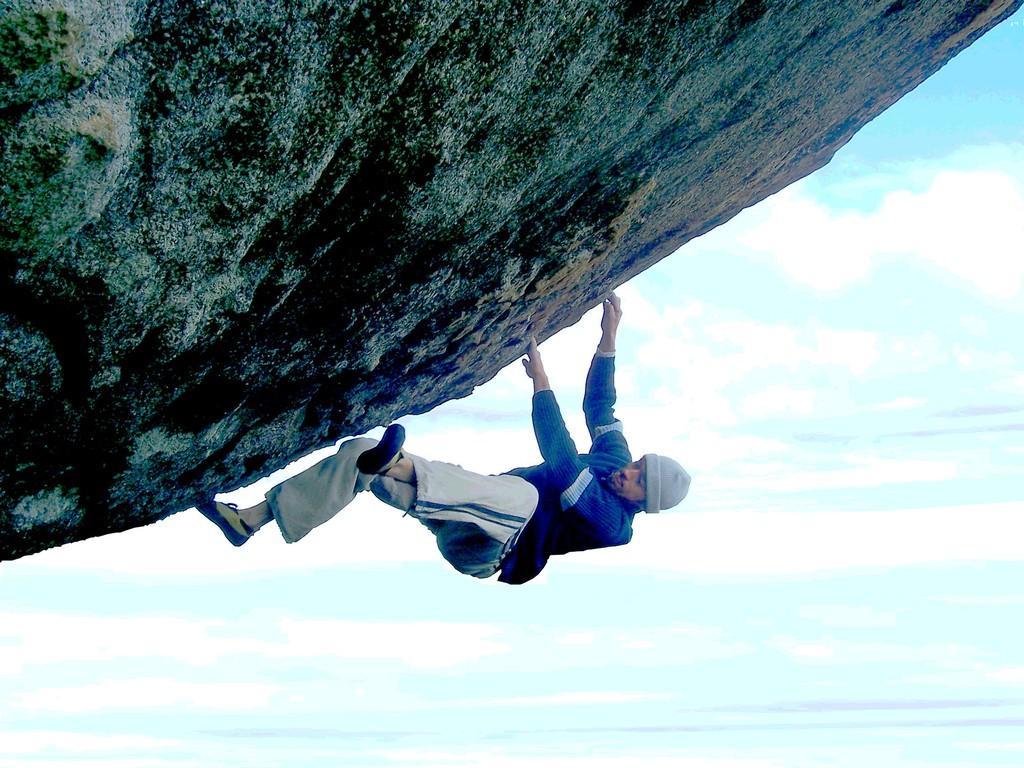Describe this image in one or two sentences. At the top of the image we can see a rock. In the middle of the image a person is climbing a rock. At the bottom of the image there are some clouds in the sky. 